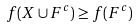<formula> <loc_0><loc_0><loc_500><loc_500>f ( X \cup F ^ { c } ) \geq f ( F ^ { c } )</formula> 